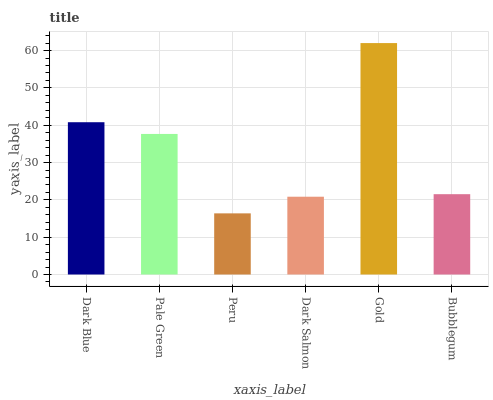Is Peru the minimum?
Answer yes or no. Yes. Is Gold the maximum?
Answer yes or no. Yes. Is Pale Green the minimum?
Answer yes or no. No. Is Pale Green the maximum?
Answer yes or no. No. Is Dark Blue greater than Pale Green?
Answer yes or no. Yes. Is Pale Green less than Dark Blue?
Answer yes or no. Yes. Is Pale Green greater than Dark Blue?
Answer yes or no. No. Is Dark Blue less than Pale Green?
Answer yes or no. No. Is Pale Green the high median?
Answer yes or no. Yes. Is Bubblegum the low median?
Answer yes or no. Yes. Is Gold the high median?
Answer yes or no. No. Is Pale Green the low median?
Answer yes or no. No. 